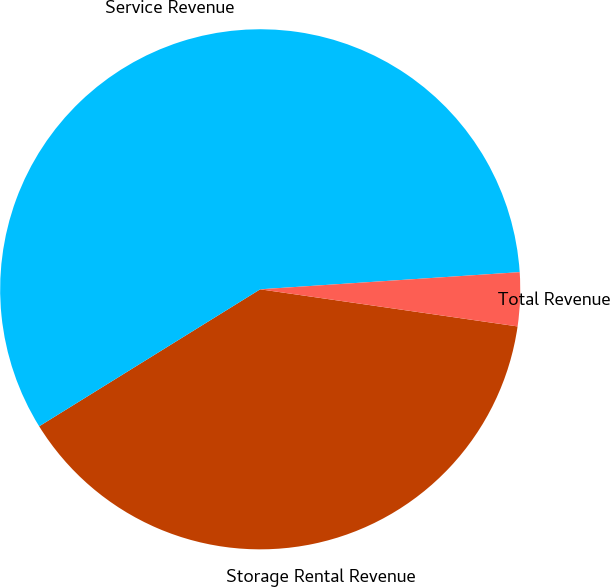Convert chart to OTSL. <chart><loc_0><loc_0><loc_500><loc_500><pie_chart><fcel>Storage Rental Revenue<fcel>Service Revenue<fcel>Total Revenue<nl><fcel>38.89%<fcel>57.78%<fcel>3.33%<nl></chart> 